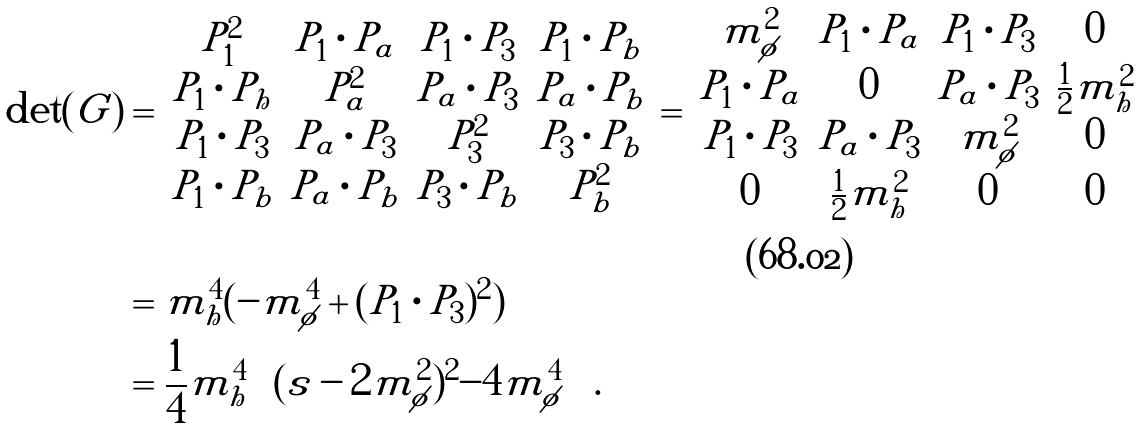Convert formula to latex. <formula><loc_0><loc_0><loc_500><loc_500>\det ( G ) & = \left | \begin{matrix} P _ { 1 } ^ { 2 } & P _ { 1 } \cdot P _ { a } & P _ { 1 } \cdot P _ { 3 } & P _ { 1 } \cdot P _ { b } \\ P _ { 1 } \cdot P _ { h } & P _ { a } ^ { 2 } & P _ { a } \cdot P _ { 3 } & P _ { a } \cdot P _ { b } \\ P _ { 1 } \cdot P _ { 3 } & P _ { a } \cdot P _ { 3 } & P _ { 3 } ^ { 2 } & P _ { 3 } \cdot P _ { b } \\ P _ { 1 } \cdot P _ { b } & P _ { a } \cdot P _ { b } & P _ { 3 } \cdot P _ { b } & P _ { b } ^ { 2 } \end{matrix} \right | = \left | \begin{matrix} m _ { \phi } ^ { 2 } & P _ { 1 } \cdot P _ { a } & P _ { 1 } \cdot P _ { 3 } & 0 \\ P _ { 1 } \cdot P _ { a } & 0 & P _ { a } \cdot P _ { 3 } & \frac { 1 } { 2 } m _ { h } ^ { 2 } \\ P _ { 1 } \cdot P _ { 3 } & P _ { a } \cdot P _ { 3 } & m _ { \phi } ^ { 2 } & 0 \\ 0 & \frac { 1 } { 2 } m _ { h } ^ { 2 } & 0 & 0 \end{matrix} \right | \\ \\ & = m _ { h } ^ { 4 } ( - m _ { \phi } ^ { 4 } + ( P _ { 1 } \cdot P _ { 3 } ) ^ { 2 } ) \\ & = \frac { 1 } { 4 } m _ { h } ^ { 4 } \left ( ( s - 2 m _ { \phi } ^ { 2 } ) ^ { 2 } - 4 m _ { \phi } ^ { 4 } \right ) \, .</formula> 